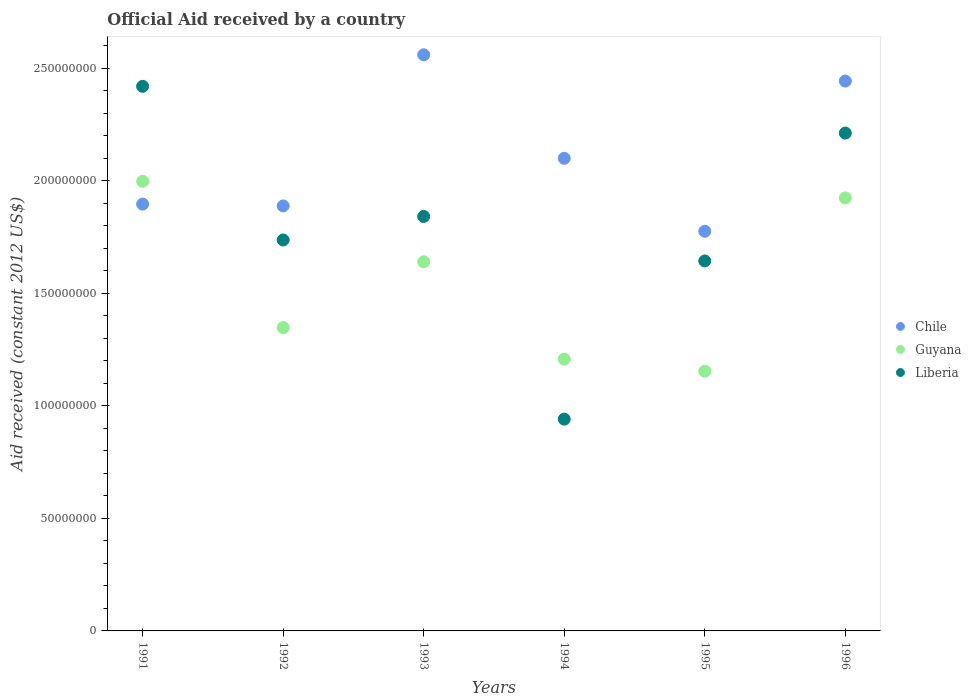How many different coloured dotlines are there?
Your answer should be very brief. 3. Is the number of dotlines equal to the number of legend labels?
Keep it short and to the point. Yes. What is the net official aid received in Chile in 1991?
Ensure brevity in your answer.  1.90e+08. Across all years, what is the maximum net official aid received in Chile?
Provide a short and direct response. 2.56e+08. Across all years, what is the minimum net official aid received in Liberia?
Keep it short and to the point. 9.41e+07. What is the total net official aid received in Chile in the graph?
Provide a short and direct response. 1.27e+09. What is the difference between the net official aid received in Guyana in 1992 and that in 1995?
Your answer should be compact. 1.94e+07. What is the difference between the net official aid received in Guyana in 1993 and the net official aid received in Liberia in 1991?
Ensure brevity in your answer.  -7.80e+07. What is the average net official aid received in Liberia per year?
Make the answer very short. 1.80e+08. In the year 1993, what is the difference between the net official aid received in Liberia and net official aid received in Chile?
Offer a terse response. -7.18e+07. In how many years, is the net official aid received in Guyana greater than 80000000 US$?
Make the answer very short. 6. What is the ratio of the net official aid received in Guyana in 1992 to that in 1996?
Make the answer very short. 0.7. What is the difference between the highest and the second highest net official aid received in Guyana?
Ensure brevity in your answer.  7.40e+06. What is the difference between the highest and the lowest net official aid received in Chile?
Your answer should be compact. 7.84e+07. In how many years, is the net official aid received in Liberia greater than the average net official aid received in Liberia taken over all years?
Your answer should be compact. 3. Is the sum of the net official aid received in Chile in 1993 and 1994 greater than the maximum net official aid received in Liberia across all years?
Your answer should be compact. Yes. How many dotlines are there?
Ensure brevity in your answer.  3. How many years are there in the graph?
Provide a short and direct response. 6. Does the graph contain grids?
Your answer should be compact. No. Where does the legend appear in the graph?
Ensure brevity in your answer.  Center right. What is the title of the graph?
Offer a terse response. Official Aid received by a country. What is the label or title of the X-axis?
Make the answer very short. Years. What is the label or title of the Y-axis?
Ensure brevity in your answer.  Aid received (constant 2012 US$). What is the Aid received (constant 2012 US$) of Chile in 1991?
Your answer should be compact. 1.90e+08. What is the Aid received (constant 2012 US$) of Guyana in 1991?
Your response must be concise. 2.00e+08. What is the Aid received (constant 2012 US$) of Liberia in 1991?
Make the answer very short. 2.42e+08. What is the Aid received (constant 2012 US$) of Chile in 1992?
Offer a terse response. 1.89e+08. What is the Aid received (constant 2012 US$) of Guyana in 1992?
Ensure brevity in your answer.  1.35e+08. What is the Aid received (constant 2012 US$) in Liberia in 1992?
Give a very brief answer. 1.74e+08. What is the Aid received (constant 2012 US$) in Chile in 1993?
Offer a very short reply. 2.56e+08. What is the Aid received (constant 2012 US$) of Guyana in 1993?
Provide a short and direct response. 1.64e+08. What is the Aid received (constant 2012 US$) of Liberia in 1993?
Provide a succinct answer. 1.84e+08. What is the Aid received (constant 2012 US$) in Chile in 1994?
Ensure brevity in your answer.  2.10e+08. What is the Aid received (constant 2012 US$) of Guyana in 1994?
Give a very brief answer. 1.21e+08. What is the Aid received (constant 2012 US$) in Liberia in 1994?
Provide a short and direct response. 9.41e+07. What is the Aid received (constant 2012 US$) in Chile in 1995?
Make the answer very short. 1.78e+08. What is the Aid received (constant 2012 US$) of Guyana in 1995?
Provide a short and direct response. 1.15e+08. What is the Aid received (constant 2012 US$) in Liberia in 1995?
Offer a very short reply. 1.64e+08. What is the Aid received (constant 2012 US$) of Chile in 1996?
Offer a terse response. 2.44e+08. What is the Aid received (constant 2012 US$) of Guyana in 1996?
Keep it short and to the point. 1.92e+08. What is the Aid received (constant 2012 US$) of Liberia in 1996?
Your response must be concise. 2.21e+08. Across all years, what is the maximum Aid received (constant 2012 US$) in Chile?
Your response must be concise. 2.56e+08. Across all years, what is the maximum Aid received (constant 2012 US$) of Guyana?
Keep it short and to the point. 2.00e+08. Across all years, what is the maximum Aid received (constant 2012 US$) in Liberia?
Provide a succinct answer. 2.42e+08. Across all years, what is the minimum Aid received (constant 2012 US$) of Chile?
Offer a very short reply. 1.78e+08. Across all years, what is the minimum Aid received (constant 2012 US$) in Guyana?
Provide a short and direct response. 1.15e+08. Across all years, what is the minimum Aid received (constant 2012 US$) of Liberia?
Your answer should be very brief. 9.41e+07. What is the total Aid received (constant 2012 US$) in Chile in the graph?
Give a very brief answer. 1.27e+09. What is the total Aid received (constant 2012 US$) of Guyana in the graph?
Provide a succinct answer. 9.27e+08. What is the total Aid received (constant 2012 US$) of Liberia in the graph?
Your answer should be very brief. 1.08e+09. What is the difference between the Aid received (constant 2012 US$) in Chile in 1991 and that in 1992?
Give a very brief answer. 8.00e+05. What is the difference between the Aid received (constant 2012 US$) in Guyana in 1991 and that in 1992?
Give a very brief answer. 6.50e+07. What is the difference between the Aid received (constant 2012 US$) in Liberia in 1991 and that in 1992?
Your response must be concise. 6.83e+07. What is the difference between the Aid received (constant 2012 US$) in Chile in 1991 and that in 1993?
Your answer should be very brief. -6.64e+07. What is the difference between the Aid received (constant 2012 US$) in Guyana in 1991 and that in 1993?
Provide a short and direct response. 3.58e+07. What is the difference between the Aid received (constant 2012 US$) of Liberia in 1991 and that in 1993?
Provide a succinct answer. 5.78e+07. What is the difference between the Aid received (constant 2012 US$) of Chile in 1991 and that in 1994?
Keep it short and to the point. -2.04e+07. What is the difference between the Aid received (constant 2012 US$) in Guyana in 1991 and that in 1994?
Your response must be concise. 7.90e+07. What is the difference between the Aid received (constant 2012 US$) of Liberia in 1991 and that in 1994?
Offer a very short reply. 1.48e+08. What is the difference between the Aid received (constant 2012 US$) of Chile in 1991 and that in 1995?
Give a very brief answer. 1.21e+07. What is the difference between the Aid received (constant 2012 US$) of Guyana in 1991 and that in 1995?
Keep it short and to the point. 8.44e+07. What is the difference between the Aid received (constant 2012 US$) of Liberia in 1991 and that in 1995?
Give a very brief answer. 7.76e+07. What is the difference between the Aid received (constant 2012 US$) of Chile in 1991 and that in 1996?
Provide a short and direct response. -5.47e+07. What is the difference between the Aid received (constant 2012 US$) in Guyana in 1991 and that in 1996?
Keep it short and to the point. 7.40e+06. What is the difference between the Aid received (constant 2012 US$) of Liberia in 1991 and that in 1996?
Ensure brevity in your answer.  2.08e+07. What is the difference between the Aid received (constant 2012 US$) in Chile in 1992 and that in 1993?
Offer a very short reply. -6.72e+07. What is the difference between the Aid received (constant 2012 US$) in Guyana in 1992 and that in 1993?
Ensure brevity in your answer.  -2.92e+07. What is the difference between the Aid received (constant 2012 US$) of Liberia in 1992 and that in 1993?
Ensure brevity in your answer.  -1.05e+07. What is the difference between the Aid received (constant 2012 US$) of Chile in 1992 and that in 1994?
Your response must be concise. -2.12e+07. What is the difference between the Aid received (constant 2012 US$) of Guyana in 1992 and that in 1994?
Offer a very short reply. 1.40e+07. What is the difference between the Aid received (constant 2012 US$) of Liberia in 1992 and that in 1994?
Make the answer very short. 7.96e+07. What is the difference between the Aid received (constant 2012 US$) in Chile in 1992 and that in 1995?
Your response must be concise. 1.13e+07. What is the difference between the Aid received (constant 2012 US$) of Guyana in 1992 and that in 1995?
Your answer should be very brief. 1.94e+07. What is the difference between the Aid received (constant 2012 US$) of Liberia in 1992 and that in 1995?
Your answer should be compact. 9.31e+06. What is the difference between the Aid received (constant 2012 US$) in Chile in 1992 and that in 1996?
Your answer should be very brief. -5.55e+07. What is the difference between the Aid received (constant 2012 US$) of Guyana in 1992 and that in 1996?
Your answer should be very brief. -5.76e+07. What is the difference between the Aid received (constant 2012 US$) in Liberia in 1992 and that in 1996?
Provide a succinct answer. -4.75e+07. What is the difference between the Aid received (constant 2012 US$) of Chile in 1993 and that in 1994?
Offer a terse response. 4.60e+07. What is the difference between the Aid received (constant 2012 US$) in Guyana in 1993 and that in 1994?
Give a very brief answer. 4.32e+07. What is the difference between the Aid received (constant 2012 US$) in Liberia in 1993 and that in 1994?
Your answer should be very brief. 9.01e+07. What is the difference between the Aid received (constant 2012 US$) of Chile in 1993 and that in 1995?
Provide a short and direct response. 7.84e+07. What is the difference between the Aid received (constant 2012 US$) of Guyana in 1993 and that in 1995?
Offer a very short reply. 4.86e+07. What is the difference between the Aid received (constant 2012 US$) of Liberia in 1993 and that in 1995?
Offer a terse response. 1.98e+07. What is the difference between the Aid received (constant 2012 US$) of Chile in 1993 and that in 1996?
Offer a very short reply. 1.17e+07. What is the difference between the Aid received (constant 2012 US$) of Guyana in 1993 and that in 1996?
Offer a very short reply. -2.84e+07. What is the difference between the Aid received (constant 2012 US$) in Liberia in 1993 and that in 1996?
Ensure brevity in your answer.  -3.70e+07. What is the difference between the Aid received (constant 2012 US$) of Chile in 1994 and that in 1995?
Provide a succinct answer. 3.24e+07. What is the difference between the Aid received (constant 2012 US$) of Guyana in 1994 and that in 1995?
Your answer should be very brief. 5.39e+06. What is the difference between the Aid received (constant 2012 US$) of Liberia in 1994 and that in 1995?
Your answer should be very brief. -7.03e+07. What is the difference between the Aid received (constant 2012 US$) in Chile in 1994 and that in 1996?
Provide a short and direct response. -3.43e+07. What is the difference between the Aid received (constant 2012 US$) in Guyana in 1994 and that in 1996?
Offer a terse response. -7.16e+07. What is the difference between the Aid received (constant 2012 US$) in Liberia in 1994 and that in 1996?
Your answer should be very brief. -1.27e+08. What is the difference between the Aid received (constant 2012 US$) of Chile in 1995 and that in 1996?
Provide a succinct answer. -6.68e+07. What is the difference between the Aid received (constant 2012 US$) of Guyana in 1995 and that in 1996?
Your answer should be compact. -7.70e+07. What is the difference between the Aid received (constant 2012 US$) in Liberia in 1995 and that in 1996?
Offer a terse response. -5.68e+07. What is the difference between the Aid received (constant 2012 US$) in Chile in 1991 and the Aid received (constant 2012 US$) in Guyana in 1992?
Offer a terse response. 5.49e+07. What is the difference between the Aid received (constant 2012 US$) in Chile in 1991 and the Aid received (constant 2012 US$) in Liberia in 1992?
Your response must be concise. 1.60e+07. What is the difference between the Aid received (constant 2012 US$) of Guyana in 1991 and the Aid received (constant 2012 US$) of Liberia in 1992?
Make the answer very short. 2.61e+07. What is the difference between the Aid received (constant 2012 US$) in Chile in 1991 and the Aid received (constant 2012 US$) in Guyana in 1993?
Ensure brevity in your answer.  2.56e+07. What is the difference between the Aid received (constant 2012 US$) of Chile in 1991 and the Aid received (constant 2012 US$) of Liberia in 1993?
Keep it short and to the point. 5.48e+06. What is the difference between the Aid received (constant 2012 US$) of Guyana in 1991 and the Aid received (constant 2012 US$) of Liberia in 1993?
Your answer should be compact. 1.56e+07. What is the difference between the Aid received (constant 2012 US$) of Chile in 1991 and the Aid received (constant 2012 US$) of Guyana in 1994?
Make the answer very short. 6.89e+07. What is the difference between the Aid received (constant 2012 US$) of Chile in 1991 and the Aid received (constant 2012 US$) of Liberia in 1994?
Provide a short and direct response. 9.56e+07. What is the difference between the Aid received (constant 2012 US$) of Guyana in 1991 and the Aid received (constant 2012 US$) of Liberia in 1994?
Offer a terse response. 1.06e+08. What is the difference between the Aid received (constant 2012 US$) of Chile in 1991 and the Aid received (constant 2012 US$) of Guyana in 1995?
Keep it short and to the point. 7.43e+07. What is the difference between the Aid received (constant 2012 US$) of Chile in 1991 and the Aid received (constant 2012 US$) of Liberia in 1995?
Offer a terse response. 2.53e+07. What is the difference between the Aid received (constant 2012 US$) of Guyana in 1991 and the Aid received (constant 2012 US$) of Liberia in 1995?
Keep it short and to the point. 3.54e+07. What is the difference between the Aid received (constant 2012 US$) of Chile in 1991 and the Aid received (constant 2012 US$) of Guyana in 1996?
Offer a terse response. -2.73e+06. What is the difference between the Aid received (constant 2012 US$) of Chile in 1991 and the Aid received (constant 2012 US$) of Liberia in 1996?
Your response must be concise. -3.16e+07. What is the difference between the Aid received (constant 2012 US$) of Guyana in 1991 and the Aid received (constant 2012 US$) of Liberia in 1996?
Offer a terse response. -2.14e+07. What is the difference between the Aid received (constant 2012 US$) of Chile in 1992 and the Aid received (constant 2012 US$) of Guyana in 1993?
Provide a short and direct response. 2.48e+07. What is the difference between the Aid received (constant 2012 US$) of Chile in 1992 and the Aid received (constant 2012 US$) of Liberia in 1993?
Your response must be concise. 4.68e+06. What is the difference between the Aid received (constant 2012 US$) in Guyana in 1992 and the Aid received (constant 2012 US$) in Liberia in 1993?
Make the answer very short. -4.94e+07. What is the difference between the Aid received (constant 2012 US$) of Chile in 1992 and the Aid received (constant 2012 US$) of Guyana in 1994?
Provide a short and direct response. 6.81e+07. What is the difference between the Aid received (constant 2012 US$) in Chile in 1992 and the Aid received (constant 2012 US$) in Liberia in 1994?
Offer a very short reply. 9.48e+07. What is the difference between the Aid received (constant 2012 US$) of Guyana in 1992 and the Aid received (constant 2012 US$) of Liberia in 1994?
Offer a terse response. 4.07e+07. What is the difference between the Aid received (constant 2012 US$) of Chile in 1992 and the Aid received (constant 2012 US$) of Guyana in 1995?
Offer a terse response. 7.35e+07. What is the difference between the Aid received (constant 2012 US$) in Chile in 1992 and the Aid received (constant 2012 US$) in Liberia in 1995?
Your response must be concise. 2.45e+07. What is the difference between the Aid received (constant 2012 US$) of Guyana in 1992 and the Aid received (constant 2012 US$) of Liberia in 1995?
Provide a short and direct response. -2.96e+07. What is the difference between the Aid received (constant 2012 US$) in Chile in 1992 and the Aid received (constant 2012 US$) in Guyana in 1996?
Ensure brevity in your answer.  -3.53e+06. What is the difference between the Aid received (constant 2012 US$) of Chile in 1992 and the Aid received (constant 2012 US$) of Liberia in 1996?
Your answer should be compact. -3.24e+07. What is the difference between the Aid received (constant 2012 US$) of Guyana in 1992 and the Aid received (constant 2012 US$) of Liberia in 1996?
Give a very brief answer. -8.64e+07. What is the difference between the Aid received (constant 2012 US$) in Chile in 1993 and the Aid received (constant 2012 US$) in Guyana in 1994?
Offer a terse response. 1.35e+08. What is the difference between the Aid received (constant 2012 US$) of Chile in 1993 and the Aid received (constant 2012 US$) of Liberia in 1994?
Offer a terse response. 1.62e+08. What is the difference between the Aid received (constant 2012 US$) in Guyana in 1993 and the Aid received (constant 2012 US$) in Liberia in 1994?
Your response must be concise. 6.99e+07. What is the difference between the Aid received (constant 2012 US$) of Chile in 1993 and the Aid received (constant 2012 US$) of Guyana in 1995?
Make the answer very short. 1.41e+08. What is the difference between the Aid received (constant 2012 US$) of Chile in 1993 and the Aid received (constant 2012 US$) of Liberia in 1995?
Keep it short and to the point. 9.16e+07. What is the difference between the Aid received (constant 2012 US$) of Guyana in 1993 and the Aid received (constant 2012 US$) of Liberia in 1995?
Provide a short and direct response. -3.80e+05. What is the difference between the Aid received (constant 2012 US$) of Chile in 1993 and the Aid received (constant 2012 US$) of Guyana in 1996?
Offer a very short reply. 6.36e+07. What is the difference between the Aid received (constant 2012 US$) of Chile in 1993 and the Aid received (constant 2012 US$) of Liberia in 1996?
Give a very brief answer. 3.48e+07. What is the difference between the Aid received (constant 2012 US$) of Guyana in 1993 and the Aid received (constant 2012 US$) of Liberia in 1996?
Give a very brief answer. -5.72e+07. What is the difference between the Aid received (constant 2012 US$) of Chile in 1994 and the Aid received (constant 2012 US$) of Guyana in 1995?
Offer a very short reply. 9.46e+07. What is the difference between the Aid received (constant 2012 US$) of Chile in 1994 and the Aid received (constant 2012 US$) of Liberia in 1995?
Provide a short and direct response. 4.56e+07. What is the difference between the Aid received (constant 2012 US$) in Guyana in 1994 and the Aid received (constant 2012 US$) in Liberia in 1995?
Give a very brief answer. -4.36e+07. What is the difference between the Aid received (constant 2012 US$) in Chile in 1994 and the Aid received (constant 2012 US$) in Guyana in 1996?
Offer a very short reply. 1.76e+07. What is the difference between the Aid received (constant 2012 US$) of Chile in 1994 and the Aid received (constant 2012 US$) of Liberia in 1996?
Provide a succinct answer. -1.12e+07. What is the difference between the Aid received (constant 2012 US$) in Guyana in 1994 and the Aid received (constant 2012 US$) in Liberia in 1996?
Offer a very short reply. -1.00e+08. What is the difference between the Aid received (constant 2012 US$) in Chile in 1995 and the Aid received (constant 2012 US$) in Guyana in 1996?
Provide a succinct answer. -1.48e+07. What is the difference between the Aid received (constant 2012 US$) of Chile in 1995 and the Aid received (constant 2012 US$) of Liberia in 1996?
Your answer should be compact. -4.36e+07. What is the difference between the Aid received (constant 2012 US$) in Guyana in 1995 and the Aid received (constant 2012 US$) in Liberia in 1996?
Offer a terse response. -1.06e+08. What is the average Aid received (constant 2012 US$) in Chile per year?
Offer a terse response. 2.11e+08. What is the average Aid received (constant 2012 US$) of Guyana per year?
Make the answer very short. 1.55e+08. What is the average Aid received (constant 2012 US$) in Liberia per year?
Make the answer very short. 1.80e+08. In the year 1991, what is the difference between the Aid received (constant 2012 US$) of Chile and Aid received (constant 2012 US$) of Guyana?
Your answer should be compact. -1.01e+07. In the year 1991, what is the difference between the Aid received (constant 2012 US$) in Chile and Aid received (constant 2012 US$) in Liberia?
Offer a very short reply. -5.24e+07. In the year 1991, what is the difference between the Aid received (constant 2012 US$) of Guyana and Aid received (constant 2012 US$) of Liberia?
Your answer should be compact. -4.22e+07. In the year 1992, what is the difference between the Aid received (constant 2012 US$) in Chile and Aid received (constant 2012 US$) in Guyana?
Ensure brevity in your answer.  5.41e+07. In the year 1992, what is the difference between the Aid received (constant 2012 US$) of Chile and Aid received (constant 2012 US$) of Liberia?
Ensure brevity in your answer.  1.52e+07. In the year 1992, what is the difference between the Aid received (constant 2012 US$) in Guyana and Aid received (constant 2012 US$) in Liberia?
Your answer should be compact. -3.89e+07. In the year 1993, what is the difference between the Aid received (constant 2012 US$) of Chile and Aid received (constant 2012 US$) of Guyana?
Offer a very short reply. 9.20e+07. In the year 1993, what is the difference between the Aid received (constant 2012 US$) in Chile and Aid received (constant 2012 US$) in Liberia?
Offer a terse response. 7.18e+07. In the year 1993, what is the difference between the Aid received (constant 2012 US$) of Guyana and Aid received (constant 2012 US$) of Liberia?
Your response must be concise. -2.02e+07. In the year 1994, what is the difference between the Aid received (constant 2012 US$) of Chile and Aid received (constant 2012 US$) of Guyana?
Give a very brief answer. 8.92e+07. In the year 1994, what is the difference between the Aid received (constant 2012 US$) in Chile and Aid received (constant 2012 US$) in Liberia?
Provide a short and direct response. 1.16e+08. In the year 1994, what is the difference between the Aid received (constant 2012 US$) in Guyana and Aid received (constant 2012 US$) in Liberia?
Your answer should be very brief. 2.67e+07. In the year 1995, what is the difference between the Aid received (constant 2012 US$) of Chile and Aid received (constant 2012 US$) of Guyana?
Your answer should be compact. 6.22e+07. In the year 1995, what is the difference between the Aid received (constant 2012 US$) of Chile and Aid received (constant 2012 US$) of Liberia?
Offer a terse response. 1.32e+07. In the year 1995, what is the difference between the Aid received (constant 2012 US$) in Guyana and Aid received (constant 2012 US$) in Liberia?
Keep it short and to the point. -4.90e+07. In the year 1996, what is the difference between the Aid received (constant 2012 US$) of Chile and Aid received (constant 2012 US$) of Guyana?
Provide a short and direct response. 5.20e+07. In the year 1996, what is the difference between the Aid received (constant 2012 US$) in Chile and Aid received (constant 2012 US$) in Liberia?
Ensure brevity in your answer.  2.31e+07. In the year 1996, what is the difference between the Aid received (constant 2012 US$) of Guyana and Aid received (constant 2012 US$) of Liberia?
Offer a terse response. -2.88e+07. What is the ratio of the Aid received (constant 2012 US$) of Chile in 1991 to that in 1992?
Your response must be concise. 1. What is the ratio of the Aid received (constant 2012 US$) of Guyana in 1991 to that in 1992?
Your answer should be very brief. 1.48. What is the ratio of the Aid received (constant 2012 US$) of Liberia in 1991 to that in 1992?
Provide a short and direct response. 1.39. What is the ratio of the Aid received (constant 2012 US$) of Chile in 1991 to that in 1993?
Your response must be concise. 0.74. What is the ratio of the Aid received (constant 2012 US$) in Guyana in 1991 to that in 1993?
Your answer should be very brief. 1.22. What is the ratio of the Aid received (constant 2012 US$) of Liberia in 1991 to that in 1993?
Give a very brief answer. 1.31. What is the ratio of the Aid received (constant 2012 US$) of Chile in 1991 to that in 1994?
Your answer should be compact. 0.9. What is the ratio of the Aid received (constant 2012 US$) of Guyana in 1991 to that in 1994?
Provide a succinct answer. 1.65. What is the ratio of the Aid received (constant 2012 US$) of Liberia in 1991 to that in 1994?
Keep it short and to the point. 2.57. What is the ratio of the Aid received (constant 2012 US$) in Chile in 1991 to that in 1995?
Offer a terse response. 1.07. What is the ratio of the Aid received (constant 2012 US$) of Guyana in 1991 to that in 1995?
Make the answer very short. 1.73. What is the ratio of the Aid received (constant 2012 US$) in Liberia in 1991 to that in 1995?
Your answer should be compact. 1.47. What is the ratio of the Aid received (constant 2012 US$) in Chile in 1991 to that in 1996?
Offer a terse response. 0.78. What is the ratio of the Aid received (constant 2012 US$) of Guyana in 1991 to that in 1996?
Offer a very short reply. 1.04. What is the ratio of the Aid received (constant 2012 US$) in Liberia in 1991 to that in 1996?
Offer a terse response. 1.09. What is the ratio of the Aid received (constant 2012 US$) of Chile in 1992 to that in 1993?
Ensure brevity in your answer.  0.74. What is the ratio of the Aid received (constant 2012 US$) in Guyana in 1992 to that in 1993?
Provide a short and direct response. 0.82. What is the ratio of the Aid received (constant 2012 US$) in Liberia in 1992 to that in 1993?
Offer a very short reply. 0.94. What is the ratio of the Aid received (constant 2012 US$) in Chile in 1992 to that in 1994?
Provide a short and direct response. 0.9. What is the ratio of the Aid received (constant 2012 US$) in Guyana in 1992 to that in 1994?
Your answer should be compact. 1.12. What is the ratio of the Aid received (constant 2012 US$) in Liberia in 1992 to that in 1994?
Give a very brief answer. 1.85. What is the ratio of the Aid received (constant 2012 US$) in Chile in 1992 to that in 1995?
Make the answer very short. 1.06. What is the ratio of the Aid received (constant 2012 US$) in Guyana in 1992 to that in 1995?
Provide a succinct answer. 1.17. What is the ratio of the Aid received (constant 2012 US$) of Liberia in 1992 to that in 1995?
Your answer should be very brief. 1.06. What is the ratio of the Aid received (constant 2012 US$) in Chile in 1992 to that in 1996?
Offer a very short reply. 0.77. What is the ratio of the Aid received (constant 2012 US$) of Guyana in 1992 to that in 1996?
Make the answer very short. 0.7. What is the ratio of the Aid received (constant 2012 US$) in Liberia in 1992 to that in 1996?
Your answer should be compact. 0.79. What is the ratio of the Aid received (constant 2012 US$) of Chile in 1993 to that in 1994?
Your answer should be compact. 1.22. What is the ratio of the Aid received (constant 2012 US$) in Guyana in 1993 to that in 1994?
Give a very brief answer. 1.36. What is the ratio of the Aid received (constant 2012 US$) in Liberia in 1993 to that in 1994?
Provide a succinct answer. 1.96. What is the ratio of the Aid received (constant 2012 US$) of Chile in 1993 to that in 1995?
Offer a terse response. 1.44. What is the ratio of the Aid received (constant 2012 US$) in Guyana in 1993 to that in 1995?
Your answer should be compact. 1.42. What is the ratio of the Aid received (constant 2012 US$) in Liberia in 1993 to that in 1995?
Provide a succinct answer. 1.12. What is the ratio of the Aid received (constant 2012 US$) of Chile in 1993 to that in 1996?
Provide a short and direct response. 1.05. What is the ratio of the Aid received (constant 2012 US$) of Guyana in 1993 to that in 1996?
Offer a very short reply. 0.85. What is the ratio of the Aid received (constant 2012 US$) of Liberia in 1993 to that in 1996?
Give a very brief answer. 0.83. What is the ratio of the Aid received (constant 2012 US$) of Chile in 1994 to that in 1995?
Your response must be concise. 1.18. What is the ratio of the Aid received (constant 2012 US$) of Guyana in 1994 to that in 1995?
Make the answer very short. 1.05. What is the ratio of the Aid received (constant 2012 US$) of Liberia in 1994 to that in 1995?
Give a very brief answer. 0.57. What is the ratio of the Aid received (constant 2012 US$) in Chile in 1994 to that in 1996?
Provide a short and direct response. 0.86. What is the ratio of the Aid received (constant 2012 US$) of Guyana in 1994 to that in 1996?
Your answer should be very brief. 0.63. What is the ratio of the Aid received (constant 2012 US$) in Liberia in 1994 to that in 1996?
Provide a succinct answer. 0.43. What is the ratio of the Aid received (constant 2012 US$) in Chile in 1995 to that in 1996?
Keep it short and to the point. 0.73. What is the ratio of the Aid received (constant 2012 US$) in Guyana in 1995 to that in 1996?
Your answer should be very brief. 0.6. What is the ratio of the Aid received (constant 2012 US$) in Liberia in 1995 to that in 1996?
Your answer should be very brief. 0.74. What is the difference between the highest and the second highest Aid received (constant 2012 US$) of Chile?
Offer a very short reply. 1.17e+07. What is the difference between the highest and the second highest Aid received (constant 2012 US$) of Guyana?
Ensure brevity in your answer.  7.40e+06. What is the difference between the highest and the second highest Aid received (constant 2012 US$) in Liberia?
Provide a short and direct response. 2.08e+07. What is the difference between the highest and the lowest Aid received (constant 2012 US$) in Chile?
Your response must be concise. 7.84e+07. What is the difference between the highest and the lowest Aid received (constant 2012 US$) of Guyana?
Make the answer very short. 8.44e+07. What is the difference between the highest and the lowest Aid received (constant 2012 US$) of Liberia?
Provide a short and direct response. 1.48e+08. 